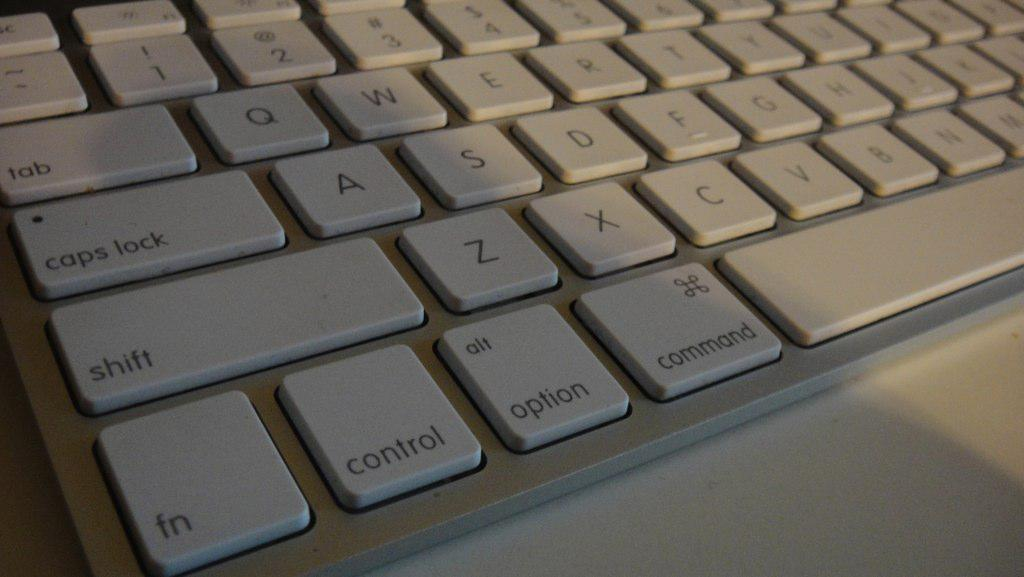<image>
Relay a brief, clear account of the picture shown. A white keyboard view on the left side of shift and control. 